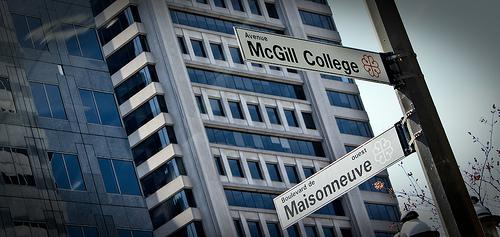Question: what is on the pole?
Choices:
A. Lights.
B. Garland.
C. Flag.
D. Street signs.
Answer with the letter. Answer: D Question: how many signs are there?
Choices:
A. One.
B. Two.
C. Three.
D. Four.
Answer with the letter. Answer: B Question: what is behind the street signs?
Choices:
A. Roads.
B. Cars.
C. Buildings.
D. Train station.
Answer with the letter. Answer: C Question: what color is one of the buildings?
Choices:
A. White.
B. Gray.
C. Tan.
D. Black.
Answer with the letter. Answer: A Question: where are the buildings?
Choices:
A. Background.
B. To the left.
C. To the right.
D. Behind.
Answer with the letter. Answer: A 